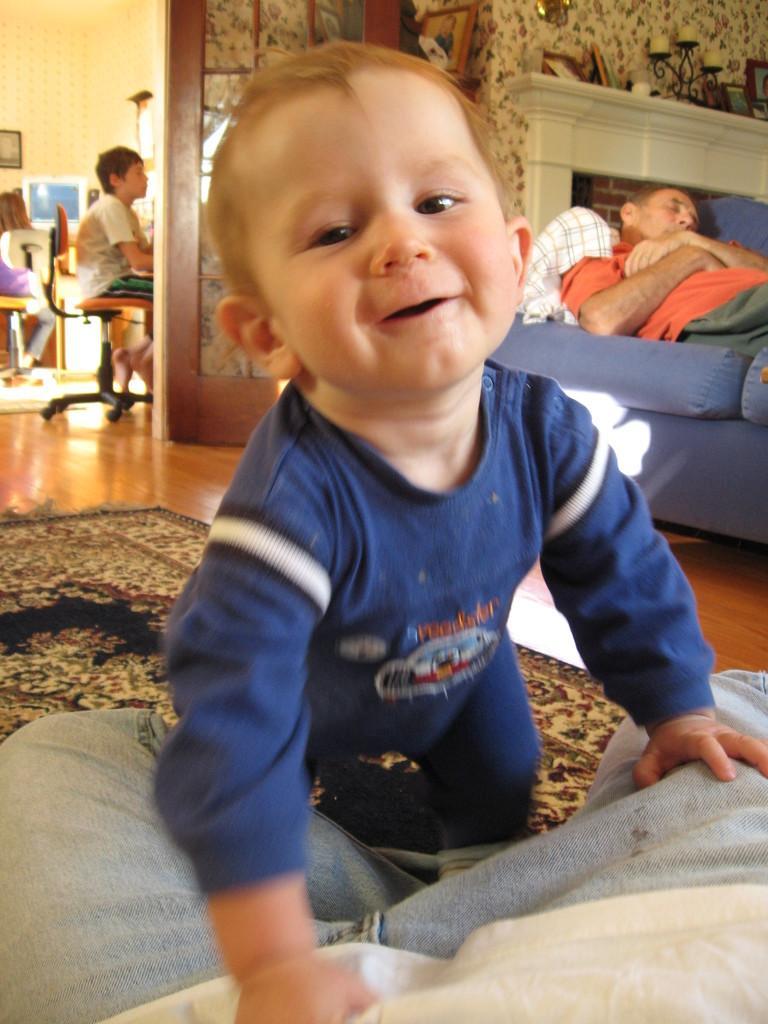Describe this image in one or two sentences. In this image I can see a boy in blue dress and a smile on his face. In the background I can see a man is lying on a sofa and a boy is sitting on a chair. 